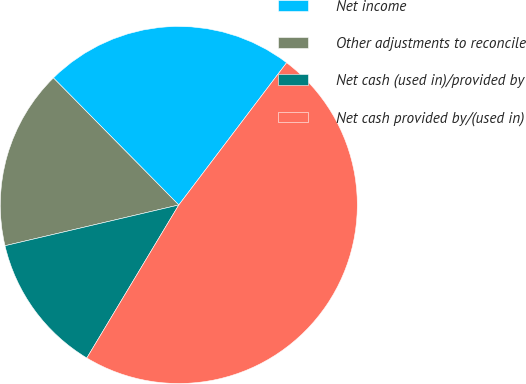Convert chart to OTSL. <chart><loc_0><loc_0><loc_500><loc_500><pie_chart><fcel>Net income<fcel>Other adjustments to reconcile<fcel>Net cash (used in)/provided by<fcel>Net cash provided by/(used in)<nl><fcel>22.72%<fcel>16.27%<fcel>12.72%<fcel>48.29%<nl></chart> 